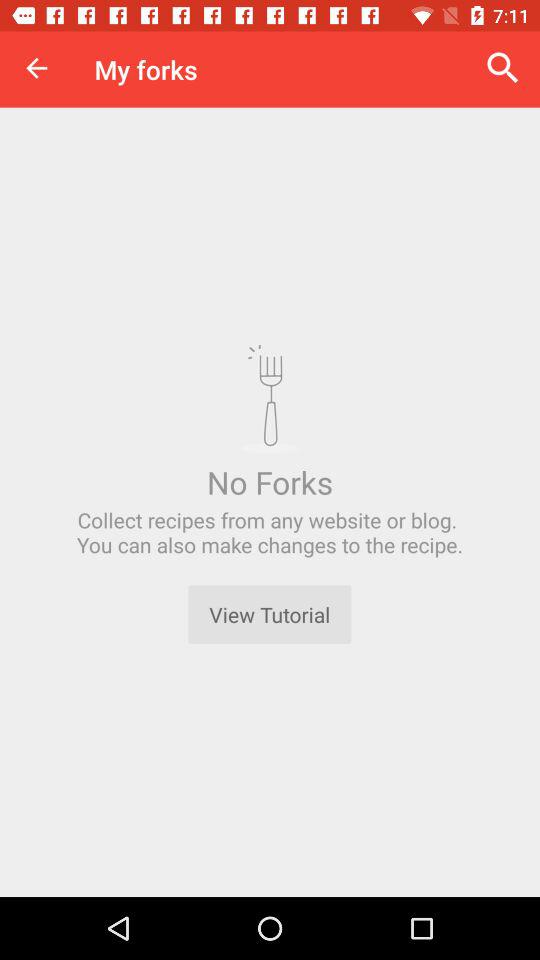How do you make changes to the recipe?
When the provided information is insufficient, respond with <no answer>. <no answer> 